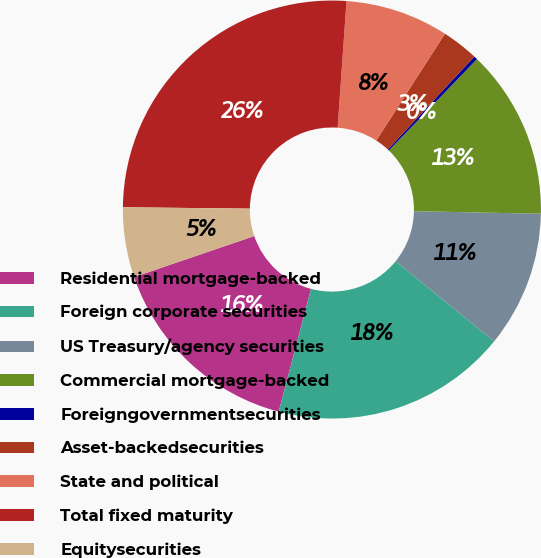<chart> <loc_0><loc_0><loc_500><loc_500><pie_chart><fcel>Residential mortgage-backed<fcel>Foreign corporate securities<fcel>US Treasury/agency securities<fcel>Commercial mortgage-backed<fcel>Foreigngovernmentsecurities<fcel>Asset-backedsecurities<fcel>State and political<fcel>Total fixed maturity<fcel>Equitysecurities<nl><fcel>15.67%<fcel>18.24%<fcel>10.54%<fcel>13.11%<fcel>0.28%<fcel>2.84%<fcel>7.98%<fcel>25.94%<fcel>5.41%<nl></chart> 